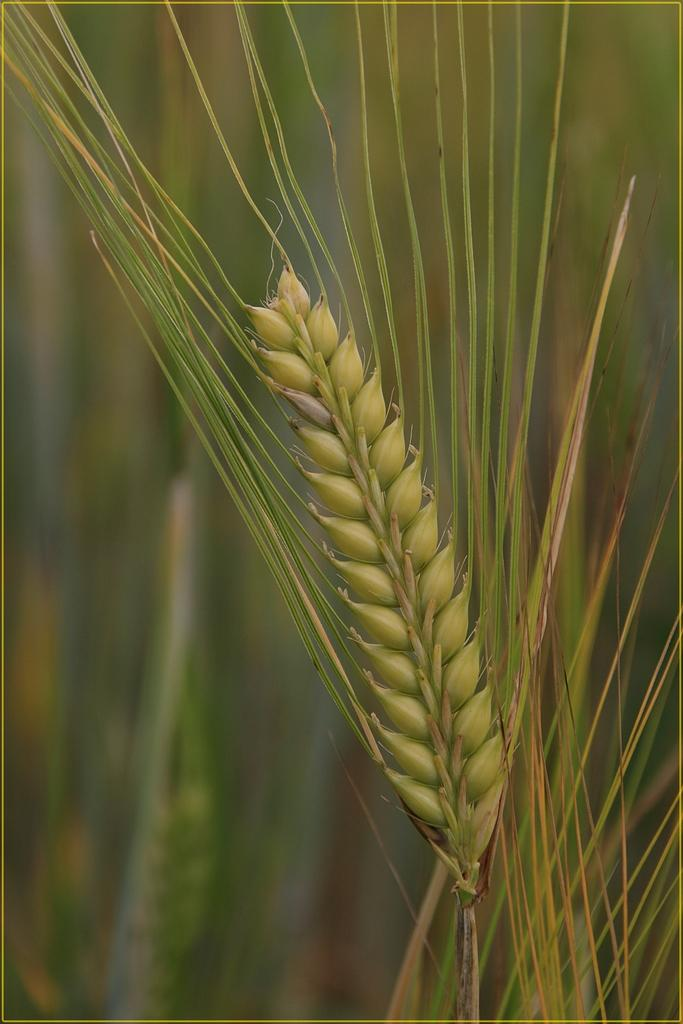What is the main subject of the image? The main subject of the image is grain buds. Where are the grain buds located in the image? The grain buds are in the center of the image. What can be seen in the background of the image? There are leaves in the background of the image. What type of stamp can be seen on the ground in the image? There is no stamp present in the image; it only features grain buds and leaves. 